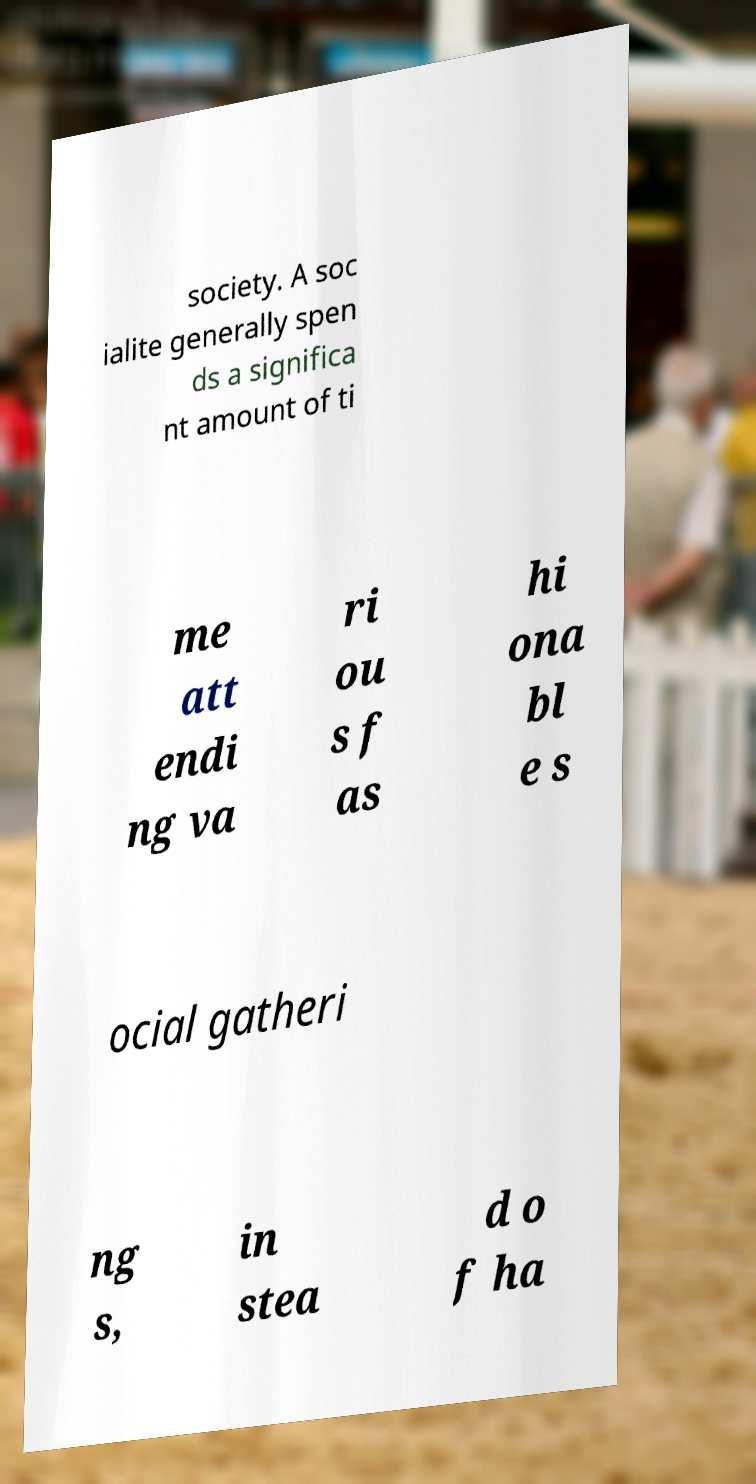Can you read and provide the text displayed in the image?This photo seems to have some interesting text. Can you extract and type it out for me? society. A soc ialite generally spen ds a significa nt amount of ti me att endi ng va ri ou s f as hi ona bl e s ocial gatheri ng s, in stea d o f ha 